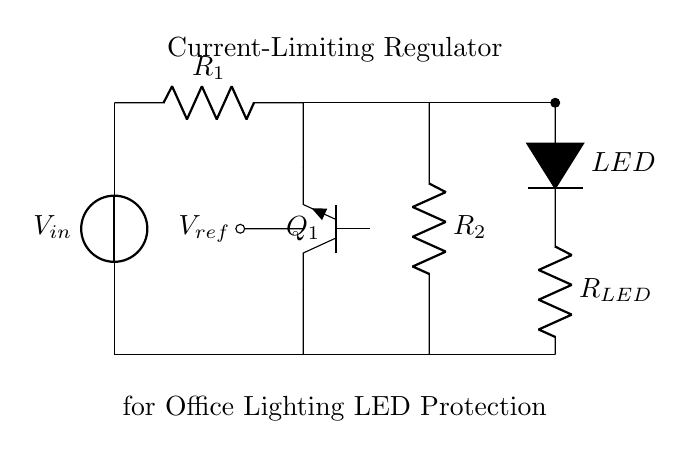What types of components are present in this circuit? The circuit includes a voltage source, resistors, a transistor, a diode, and an LED. Each component plays a specific role in regulating current and ensuring proper LED operation.
Answer: voltage source, resistors, transistor, diode, LED What is the function of the transistor in this circuit? The transistor acts as a current-limiting device, regulating the amount of current flowing to the LED based on the reference voltage provided, thus protecting the LED from overcurrent.
Answer: current-limiting What does the reference voltage represent in this circuit? The reference voltage, indicated by V_ref, establishes the threshold for controlling the transistor, which helps determine how much current can pass through to the LED, ensuring safe operation.
Answer: control threshold What would happen if the resistance of R1 is increased? Increasing R1 will reduce the base current into the transistor, potentially leading to a decrease in the collector current that powers the LED, which might result in lower brightness of the LED.
Answer: reduced brightness How does this circuit limit current to protect the LED? The regulation occurs through the feedback mechanism involving R1 and V_ref, which adjusts the base voltage of the transistor, limiting the current based on the set reference level, ensuring consistent safe current flow.
Answer: feedback mechanism What is the role of resistor R_LED in this circuit? Resistor R_LED limits the current that can flow through the LED to prevent it from experiencing excessive current, thereby extending its lifespan and maintaining proper functionality.
Answer: current limiter 